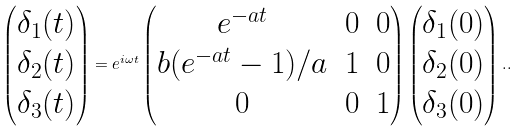Convert formula to latex. <formula><loc_0><loc_0><loc_500><loc_500>\begin{pmatrix} \delta _ { 1 } ( t ) \\ \delta _ { 2 } ( t ) \\ \delta _ { 3 } ( t ) \end{pmatrix} = e ^ { i \omega t } \begin{pmatrix} e ^ { - a t } & 0 & 0 \\ b ( e ^ { - a t } - 1 ) / a & 1 & 0 \\ 0 & 0 & 1 \end{pmatrix} \begin{pmatrix} \delta _ { 1 } ( 0 ) \\ \delta _ { 2 } ( 0 ) \\ \delta _ { 3 } ( 0 ) \end{pmatrix} . .</formula> 